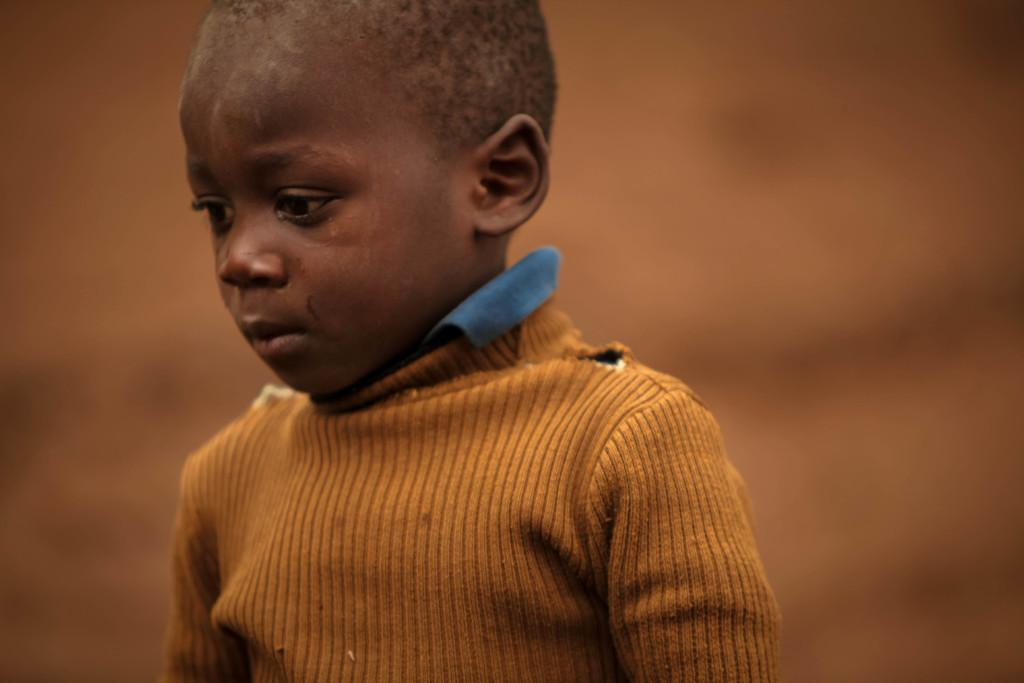What is the main subject of the image? The main subject of the image is a kid. What can be observed about the kid's attire? The kid is wearing clothes. How would you describe the background of the image? The background of the image is blurred. How many men are visible in the image? There are no men visible in the image; it features a kid. What season is depicted in the image? The image does not depict a specific season, as the background is blurred and no seasonal elements are present. 